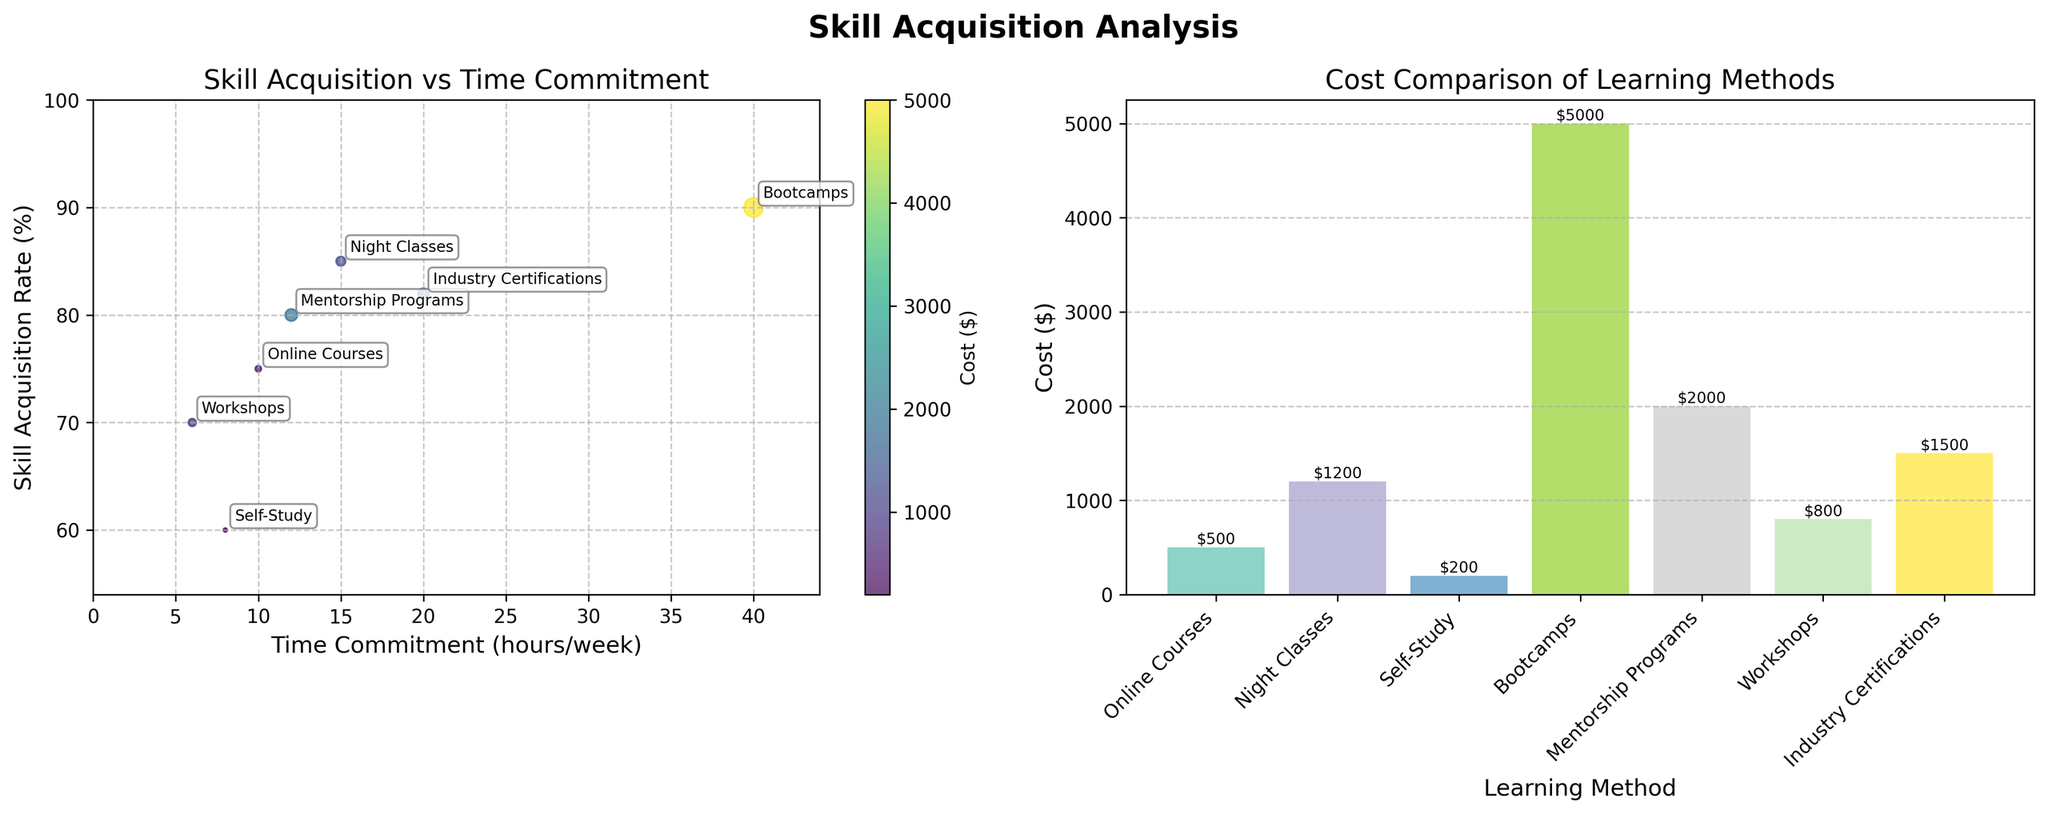What is the highest skill acquisition rate? To find the highest skill acquisition rate, look at the y-axis of the first subplot. Check for the highest point along this axis. The maximum value is at "Bootcamps" with a skill acquisition rate of 90%.
Answer: 90% Which learning method has the lowest cost? To determine the lowest cost, look at the height of the bars in the second subplot. The bar with the shortest height represents the lowest cost, which is "Self-Study" at $200.
Answer: Self-Study What is the range of time commitment for all learning methods? To find the range, look at the x-axis of the first subplot for the time commitment values. The minimum value is for "Workshops" at 6 hours/week, while the maximum value is for "Bootcamps" at 40 hours/week. Thus, the range is 40 - 6 = 34 hours/week.
Answer: 34 hours/week Which learning method requires the most time commitment per week? To determine this, check the x-axis of the first subplot. The method that extends furthest to the right is "Bootcamps" with a time commitment of 40 hours/week.
Answer: Bootcamps How does the cost of night classes compare to that of online courses? To compare, look at the height of the bars in the second subplot for "Night Classes" and "Online Courses". "Night Classes" costs $1200, whereas "Online Courses" costs $500. Therefore, night classes are more expensive by $700.
Answer: Night Classes are $700 more expensive Which learning method has the highest skill acquisition rate but also a high cost? Check both the highest points along the y-axis in the first subplot and the corresponding bar heights in the second subplot. "Bootcamps" has the highest skill acquisition rate (90%) and a high cost of $5000.
Answer: Bootcamps Which method is the most cost-efficient in terms of skill acquisition per dollar spent? To find the most cost-efficient method, calculate the skill acquisition rate per dollar for each method. "Self-Study" has a skill acquisition rate of 60% and costs $200, giving a ratio of 0.3 (60/200). This is the highest ratio among all methods, making it the most cost-efficient.
Answer: Self-Study What is the average skill acquisition rate across all learning methods? Add up all skill acquisition rates and divide by the number of methods. The total is 75+85+60+90+80+70+82=542. Dividing this by 7 methods gives an average rate of 77.4%.
Answer: 77.4% 